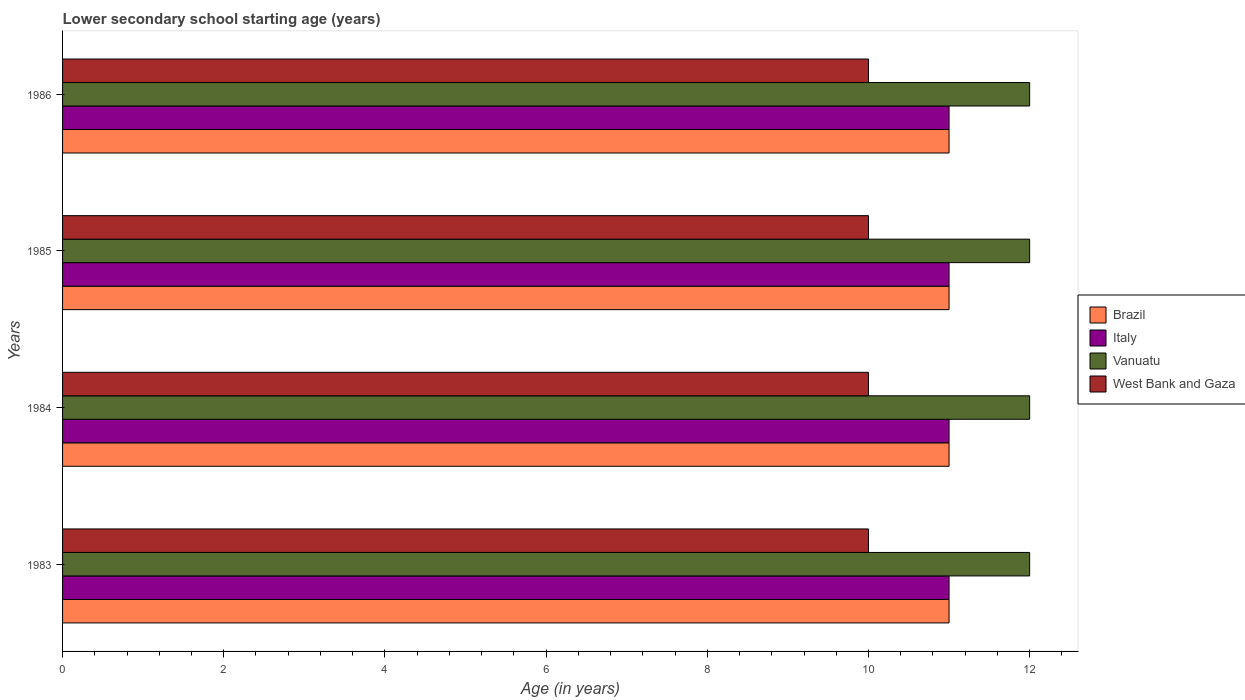How many groups of bars are there?
Your answer should be very brief. 4. Are the number of bars per tick equal to the number of legend labels?
Provide a short and direct response. Yes. What is the label of the 1st group of bars from the top?
Make the answer very short. 1986. What is the lower secondary school starting age of children in Brazil in 1985?
Offer a very short reply. 11. Across all years, what is the maximum lower secondary school starting age of children in Brazil?
Provide a short and direct response. 11. Across all years, what is the minimum lower secondary school starting age of children in Vanuatu?
Offer a terse response. 12. In which year was the lower secondary school starting age of children in Brazil maximum?
Your response must be concise. 1983. What is the total lower secondary school starting age of children in Vanuatu in the graph?
Offer a very short reply. 48. What is the difference between the lower secondary school starting age of children in Italy in 1985 and that in 1986?
Keep it short and to the point. 0. What is the difference between the lower secondary school starting age of children in Italy in 1985 and the lower secondary school starting age of children in West Bank and Gaza in 1984?
Keep it short and to the point. 1. In the year 1983, what is the difference between the lower secondary school starting age of children in West Bank and Gaza and lower secondary school starting age of children in Vanuatu?
Offer a very short reply. -2. What is the ratio of the lower secondary school starting age of children in Italy in 1983 to that in 1984?
Offer a very short reply. 1. What is the difference between the highest and the lowest lower secondary school starting age of children in Brazil?
Provide a succinct answer. 0. In how many years, is the lower secondary school starting age of children in Vanuatu greater than the average lower secondary school starting age of children in Vanuatu taken over all years?
Offer a very short reply. 0. What does the 4th bar from the bottom in 1985 represents?
Keep it short and to the point. West Bank and Gaza. How many bars are there?
Your response must be concise. 16. How many years are there in the graph?
Offer a terse response. 4. Are the values on the major ticks of X-axis written in scientific E-notation?
Provide a short and direct response. No. Does the graph contain any zero values?
Make the answer very short. No. Where does the legend appear in the graph?
Offer a terse response. Center right. How many legend labels are there?
Give a very brief answer. 4. What is the title of the graph?
Provide a succinct answer. Lower secondary school starting age (years). What is the label or title of the X-axis?
Make the answer very short. Age (in years). What is the label or title of the Y-axis?
Provide a short and direct response. Years. What is the Age (in years) in Brazil in 1983?
Provide a succinct answer. 11. What is the Age (in years) in Vanuatu in 1983?
Your answer should be compact. 12. What is the Age (in years) of West Bank and Gaza in 1983?
Provide a short and direct response. 10. What is the Age (in years) in Italy in 1984?
Offer a terse response. 11. What is the Age (in years) of Vanuatu in 1984?
Your response must be concise. 12. What is the Age (in years) in Italy in 1985?
Offer a very short reply. 11. What is the Age (in years) in Vanuatu in 1985?
Offer a terse response. 12. What is the Age (in years) of Brazil in 1986?
Your response must be concise. 11. What is the Age (in years) in Italy in 1986?
Offer a very short reply. 11. What is the Age (in years) of West Bank and Gaza in 1986?
Give a very brief answer. 10. Across all years, what is the minimum Age (in years) of Vanuatu?
Ensure brevity in your answer.  12. Across all years, what is the minimum Age (in years) of West Bank and Gaza?
Give a very brief answer. 10. What is the total Age (in years) in Brazil in the graph?
Your answer should be very brief. 44. What is the total Age (in years) of Italy in the graph?
Ensure brevity in your answer.  44. What is the difference between the Age (in years) in Brazil in 1983 and that in 1984?
Provide a short and direct response. 0. What is the difference between the Age (in years) of Italy in 1983 and that in 1984?
Make the answer very short. 0. What is the difference between the Age (in years) of Vanuatu in 1983 and that in 1984?
Give a very brief answer. 0. What is the difference between the Age (in years) of West Bank and Gaza in 1983 and that in 1984?
Your answer should be compact. 0. What is the difference between the Age (in years) in Vanuatu in 1983 and that in 1986?
Keep it short and to the point. 0. What is the difference between the Age (in years) of West Bank and Gaza in 1983 and that in 1986?
Ensure brevity in your answer.  0. What is the difference between the Age (in years) in Italy in 1984 and that in 1985?
Provide a short and direct response. 0. What is the difference between the Age (in years) in West Bank and Gaza in 1984 and that in 1986?
Offer a very short reply. 0. What is the difference between the Age (in years) in Vanuatu in 1985 and that in 1986?
Your answer should be very brief. 0. What is the difference between the Age (in years) of West Bank and Gaza in 1985 and that in 1986?
Provide a short and direct response. 0. What is the difference between the Age (in years) in Brazil in 1983 and the Age (in years) in Italy in 1984?
Your answer should be very brief. 0. What is the difference between the Age (in years) in Brazil in 1983 and the Age (in years) in West Bank and Gaza in 1984?
Your response must be concise. 1. What is the difference between the Age (in years) in Italy in 1983 and the Age (in years) in Vanuatu in 1984?
Ensure brevity in your answer.  -1. What is the difference between the Age (in years) of Vanuatu in 1983 and the Age (in years) of West Bank and Gaza in 1984?
Give a very brief answer. 2. What is the difference between the Age (in years) of Brazil in 1983 and the Age (in years) of Italy in 1985?
Your answer should be compact. 0. What is the difference between the Age (in years) in Brazil in 1983 and the Age (in years) in Vanuatu in 1985?
Offer a terse response. -1. What is the difference between the Age (in years) in Italy in 1983 and the Age (in years) in Vanuatu in 1985?
Provide a short and direct response. -1. What is the difference between the Age (in years) in Brazil in 1983 and the Age (in years) in Italy in 1986?
Keep it short and to the point. 0. What is the difference between the Age (in years) in Italy in 1983 and the Age (in years) in Vanuatu in 1986?
Ensure brevity in your answer.  -1. What is the difference between the Age (in years) of Italy in 1983 and the Age (in years) of West Bank and Gaza in 1986?
Provide a short and direct response. 1. What is the difference between the Age (in years) of Vanuatu in 1983 and the Age (in years) of West Bank and Gaza in 1986?
Your answer should be very brief. 2. What is the difference between the Age (in years) of Brazil in 1984 and the Age (in years) of Vanuatu in 1985?
Make the answer very short. -1. What is the difference between the Age (in years) of Brazil in 1984 and the Age (in years) of West Bank and Gaza in 1985?
Make the answer very short. 1. What is the difference between the Age (in years) of Italy in 1984 and the Age (in years) of West Bank and Gaza in 1985?
Give a very brief answer. 1. What is the difference between the Age (in years) in Vanuatu in 1984 and the Age (in years) in West Bank and Gaza in 1985?
Provide a succinct answer. 2. What is the difference between the Age (in years) of Brazil in 1984 and the Age (in years) of Italy in 1986?
Your response must be concise. 0. What is the difference between the Age (in years) of Brazil in 1984 and the Age (in years) of West Bank and Gaza in 1986?
Your response must be concise. 1. What is the difference between the Age (in years) of Italy in 1984 and the Age (in years) of West Bank and Gaza in 1986?
Your response must be concise. 1. What is the difference between the Age (in years) in Vanuatu in 1984 and the Age (in years) in West Bank and Gaza in 1986?
Give a very brief answer. 2. What is the difference between the Age (in years) of Brazil in 1985 and the Age (in years) of Vanuatu in 1986?
Make the answer very short. -1. What is the difference between the Age (in years) in Italy in 1985 and the Age (in years) in Vanuatu in 1986?
Ensure brevity in your answer.  -1. What is the difference between the Age (in years) in Italy in 1985 and the Age (in years) in West Bank and Gaza in 1986?
Provide a succinct answer. 1. What is the average Age (in years) in Italy per year?
Make the answer very short. 11. What is the average Age (in years) in West Bank and Gaza per year?
Your answer should be very brief. 10. In the year 1983, what is the difference between the Age (in years) of Brazil and Age (in years) of Italy?
Your answer should be compact. 0. In the year 1983, what is the difference between the Age (in years) in Brazil and Age (in years) in Vanuatu?
Your answer should be compact. -1. In the year 1983, what is the difference between the Age (in years) in Brazil and Age (in years) in West Bank and Gaza?
Keep it short and to the point. 1. In the year 1983, what is the difference between the Age (in years) of Italy and Age (in years) of West Bank and Gaza?
Make the answer very short. 1. In the year 1983, what is the difference between the Age (in years) of Vanuatu and Age (in years) of West Bank and Gaza?
Your answer should be very brief. 2. In the year 1984, what is the difference between the Age (in years) of Brazil and Age (in years) of Vanuatu?
Offer a very short reply. -1. In the year 1984, what is the difference between the Age (in years) of Italy and Age (in years) of Vanuatu?
Your response must be concise. -1. In the year 1985, what is the difference between the Age (in years) of Brazil and Age (in years) of West Bank and Gaza?
Make the answer very short. 1. In the year 1985, what is the difference between the Age (in years) of Italy and Age (in years) of West Bank and Gaza?
Provide a succinct answer. 1. In the year 1986, what is the difference between the Age (in years) in Brazil and Age (in years) in West Bank and Gaza?
Offer a terse response. 1. In the year 1986, what is the difference between the Age (in years) in Italy and Age (in years) in Vanuatu?
Give a very brief answer. -1. In the year 1986, what is the difference between the Age (in years) of Vanuatu and Age (in years) of West Bank and Gaza?
Make the answer very short. 2. What is the ratio of the Age (in years) in Italy in 1983 to that in 1984?
Provide a short and direct response. 1. What is the ratio of the Age (in years) of Vanuatu in 1983 to that in 1984?
Your response must be concise. 1. What is the ratio of the Age (in years) of West Bank and Gaza in 1983 to that in 1984?
Offer a very short reply. 1. What is the ratio of the Age (in years) in Brazil in 1983 to that in 1985?
Keep it short and to the point. 1. What is the ratio of the Age (in years) of Italy in 1983 to that in 1985?
Provide a short and direct response. 1. What is the ratio of the Age (in years) of Vanuatu in 1983 to that in 1985?
Your answer should be compact. 1. What is the ratio of the Age (in years) of Italy in 1983 to that in 1986?
Keep it short and to the point. 1. What is the ratio of the Age (in years) of Vanuatu in 1983 to that in 1986?
Your answer should be compact. 1. What is the ratio of the Age (in years) of West Bank and Gaza in 1983 to that in 1986?
Offer a terse response. 1. What is the ratio of the Age (in years) of Italy in 1984 to that in 1986?
Provide a succinct answer. 1. What is the ratio of the Age (in years) in West Bank and Gaza in 1984 to that in 1986?
Your answer should be very brief. 1. What is the ratio of the Age (in years) in Vanuatu in 1985 to that in 1986?
Your response must be concise. 1. What is the ratio of the Age (in years) of West Bank and Gaza in 1985 to that in 1986?
Provide a succinct answer. 1. What is the difference between the highest and the second highest Age (in years) in Brazil?
Keep it short and to the point. 0. What is the difference between the highest and the second highest Age (in years) of Vanuatu?
Your response must be concise. 0. What is the difference between the highest and the lowest Age (in years) of West Bank and Gaza?
Ensure brevity in your answer.  0. 